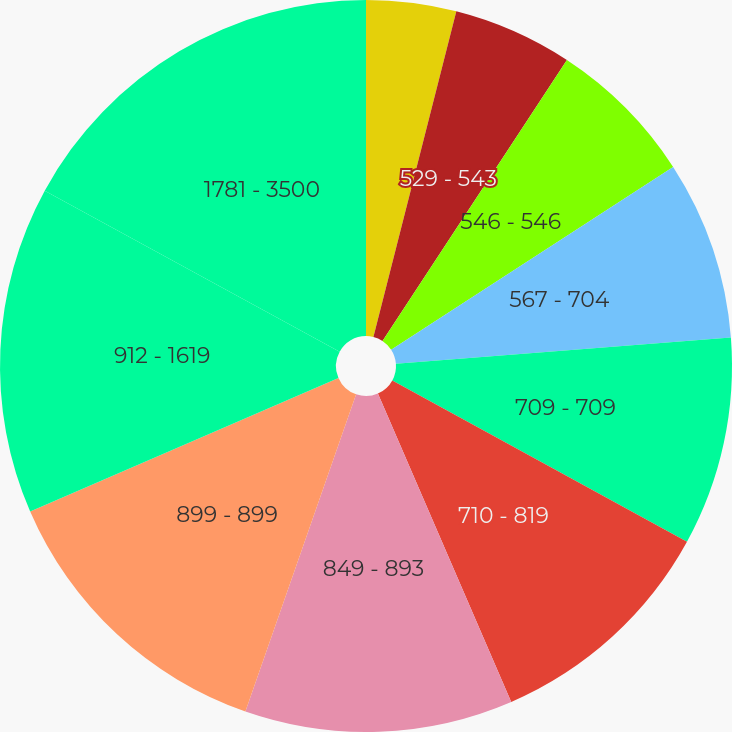<chart> <loc_0><loc_0><loc_500><loc_500><pie_chart><fcel>310 - 524<fcel>529 - 543<fcel>546 - 546<fcel>567 - 704<fcel>709 - 709<fcel>710 - 819<fcel>849 - 893<fcel>899 - 899<fcel>912 - 1619<fcel>1781 - 3500<nl><fcel>3.97%<fcel>5.28%<fcel>6.6%<fcel>7.91%<fcel>9.22%<fcel>10.53%<fcel>11.84%<fcel>13.15%<fcel>14.46%<fcel>17.05%<nl></chart> 